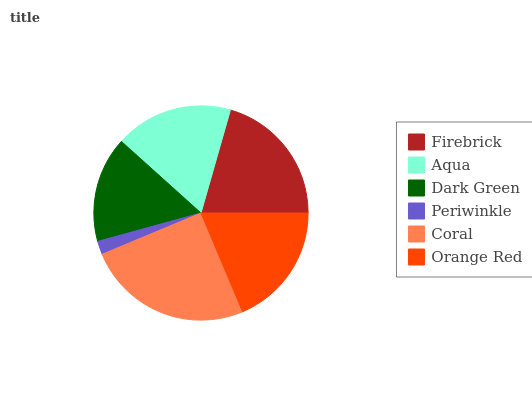Is Periwinkle the minimum?
Answer yes or no. Yes. Is Coral the maximum?
Answer yes or no. Yes. Is Aqua the minimum?
Answer yes or no. No. Is Aqua the maximum?
Answer yes or no. No. Is Firebrick greater than Aqua?
Answer yes or no. Yes. Is Aqua less than Firebrick?
Answer yes or no. Yes. Is Aqua greater than Firebrick?
Answer yes or no. No. Is Firebrick less than Aqua?
Answer yes or no. No. Is Orange Red the high median?
Answer yes or no. Yes. Is Aqua the low median?
Answer yes or no. Yes. Is Periwinkle the high median?
Answer yes or no. No. Is Dark Green the low median?
Answer yes or no. No. 